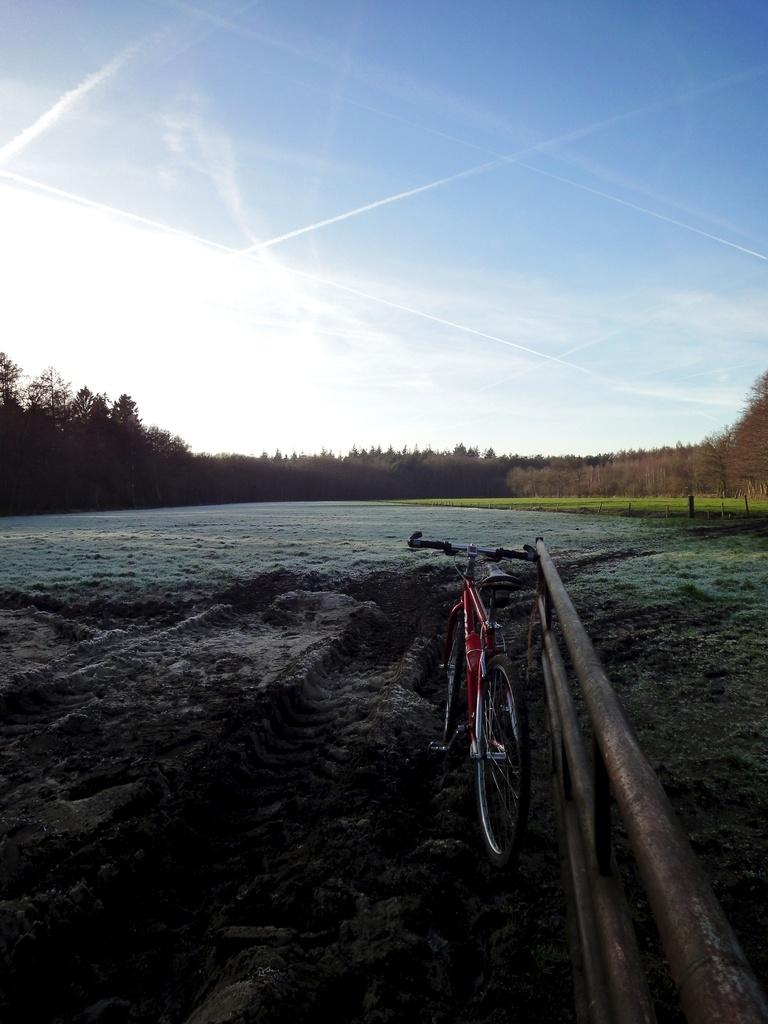What is the main object in the image? There is a bicycle in the image. What is the condition of the ground where the bicycle is located? The bicycle is on the mud. What type of natural environment can be seen in the image? There are trees in the image. What is visible in the background of the image? The sky is visible in the background of the image. What type of wax can be seen dripping from the trees in the image? There is no wax present in the image; the trees are not depicted as dripping wax. 